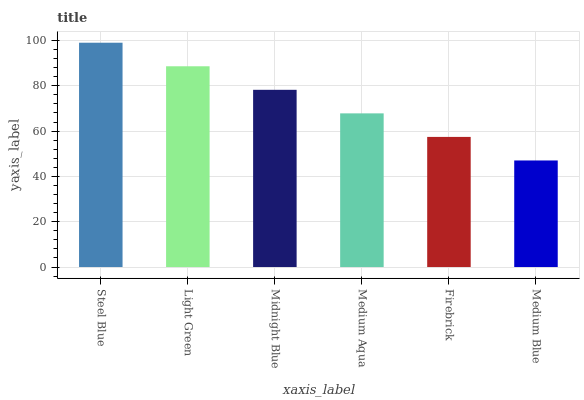Is Medium Blue the minimum?
Answer yes or no. Yes. Is Steel Blue the maximum?
Answer yes or no. Yes. Is Light Green the minimum?
Answer yes or no. No. Is Light Green the maximum?
Answer yes or no. No. Is Steel Blue greater than Light Green?
Answer yes or no. Yes. Is Light Green less than Steel Blue?
Answer yes or no. Yes. Is Light Green greater than Steel Blue?
Answer yes or no. No. Is Steel Blue less than Light Green?
Answer yes or no. No. Is Midnight Blue the high median?
Answer yes or no. Yes. Is Medium Aqua the low median?
Answer yes or no. Yes. Is Light Green the high median?
Answer yes or no. No. Is Firebrick the low median?
Answer yes or no. No. 